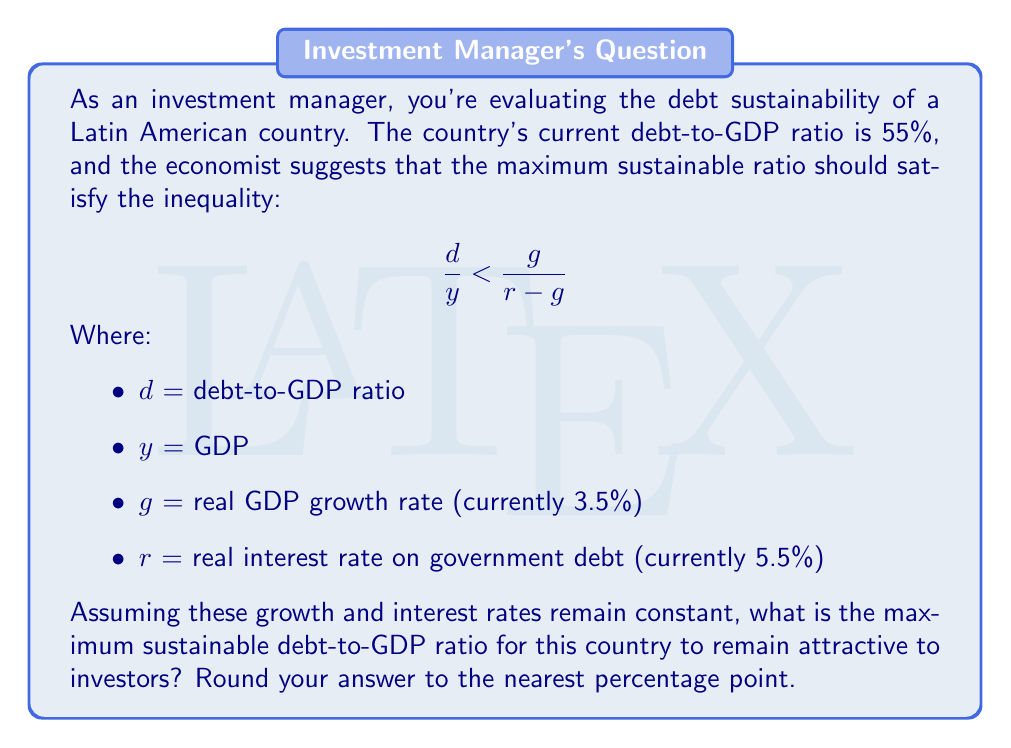Solve this math problem. To solve this problem, we need to use the given inequality and the provided values:

1. The inequality: $\frac{d}{y} < \frac{g}{r-g}$

2. Given values:
   $g = 3.5\% = 0.035$
   $r = 5.5\% = 0.055$

3. Let's calculate the right side of the inequality:

   $\frac{g}{r-g} = \frac{0.035}{0.055 - 0.035} = \frac{0.035}{0.02} = 1.75$

4. This means that the maximum sustainable debt-to-GDP ratio should be less than 1.75, or 175%.

5. However, in practice, a debt-to-GDP ratio this high would likely be considered risky by investors. A more conservative approach would be to aim for a ratio significantly below this theoretical maximum.

6. As an investment manager, you might consider a buffer of about 25-30% below the theoretical maximum to account for economic uncertainties and maintain attractiveness to investors.

7. Applying a 30% buffer: $175\% \times (1 - 0.30) = 122.5\%$

8. Rounding to the nearest percentage point: 123%
Answer: The maximum sustainable debt-to-GDP ratio for this Latin American country to remain attractive to investors is approximately 123%. 